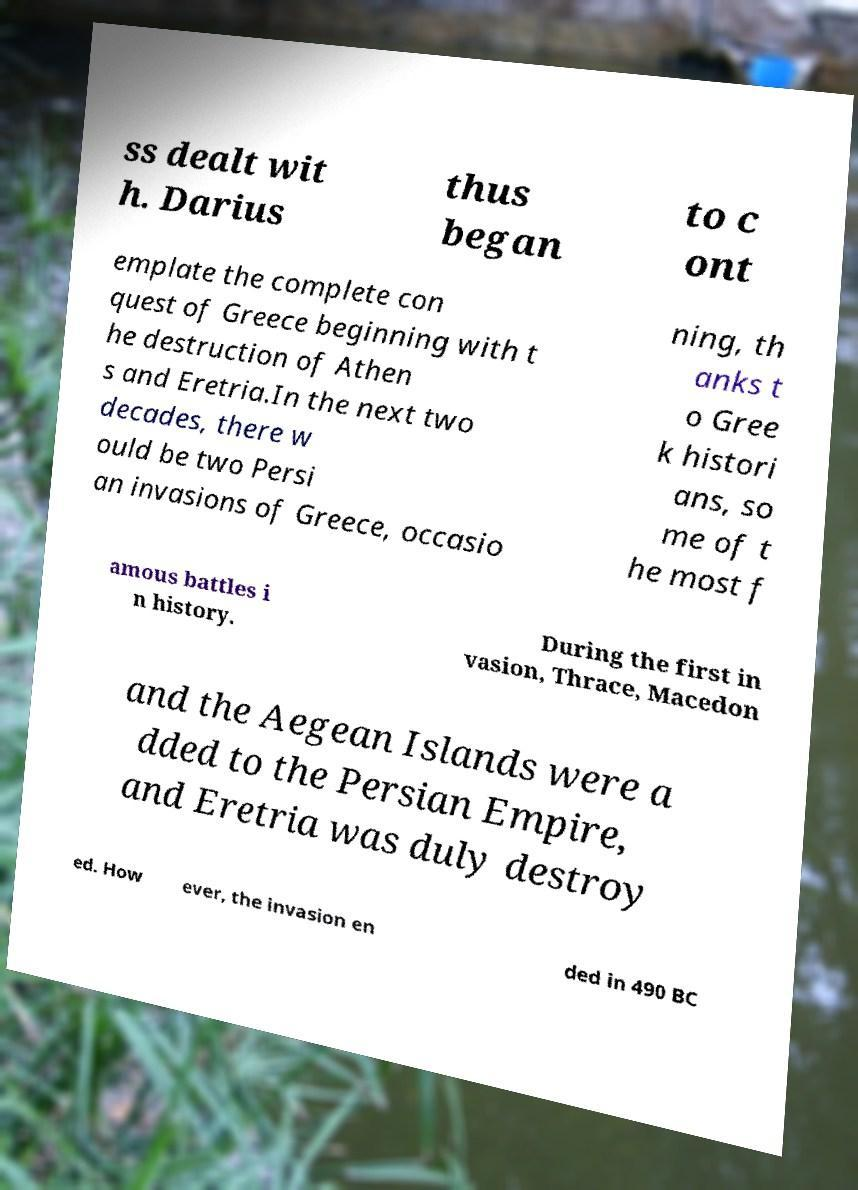There's text embedded in this image that I need extracted. Can you transcribe it verbatim? ss dealt wit h. Darius thus began to c ont emplate the complete con quest of Greece beginning with t he destruction of Athen s and Eretria.In the next two decades, there w ould be two Persi an invasions of Greece, occasio ning, th anks t o Gree k histori ans, so me of t he most f amous battles i n history. During the first in vasion, Thrace, Macedon and the Aegean Islands were a dded to the Persian Empire, and Eretria was duly destroy ed. How ever, the invasion en ded in 490 BC 